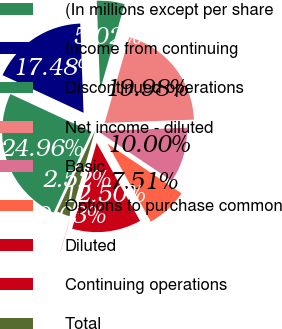<chart> <loc_0><loc_0><loc_500><loc_500><pie_chart><fcel>(In millions except per share<fcel>Income from continuing<fcel>Discontinued operations<fcel>Net income - diluted<fcel>Basic<fcel>Options to purchase common<fcel>Diluted<fcel>Continuing operations<fcel>Total<nl><fcel>24.96%<fcel>17.48%<fcel>5.02%<fcel>19.98%<fcel>10.0%<fcel>7.51%<fcel>12.5%<fcel>0.03%<fcel>2.52%<nl></chart> 